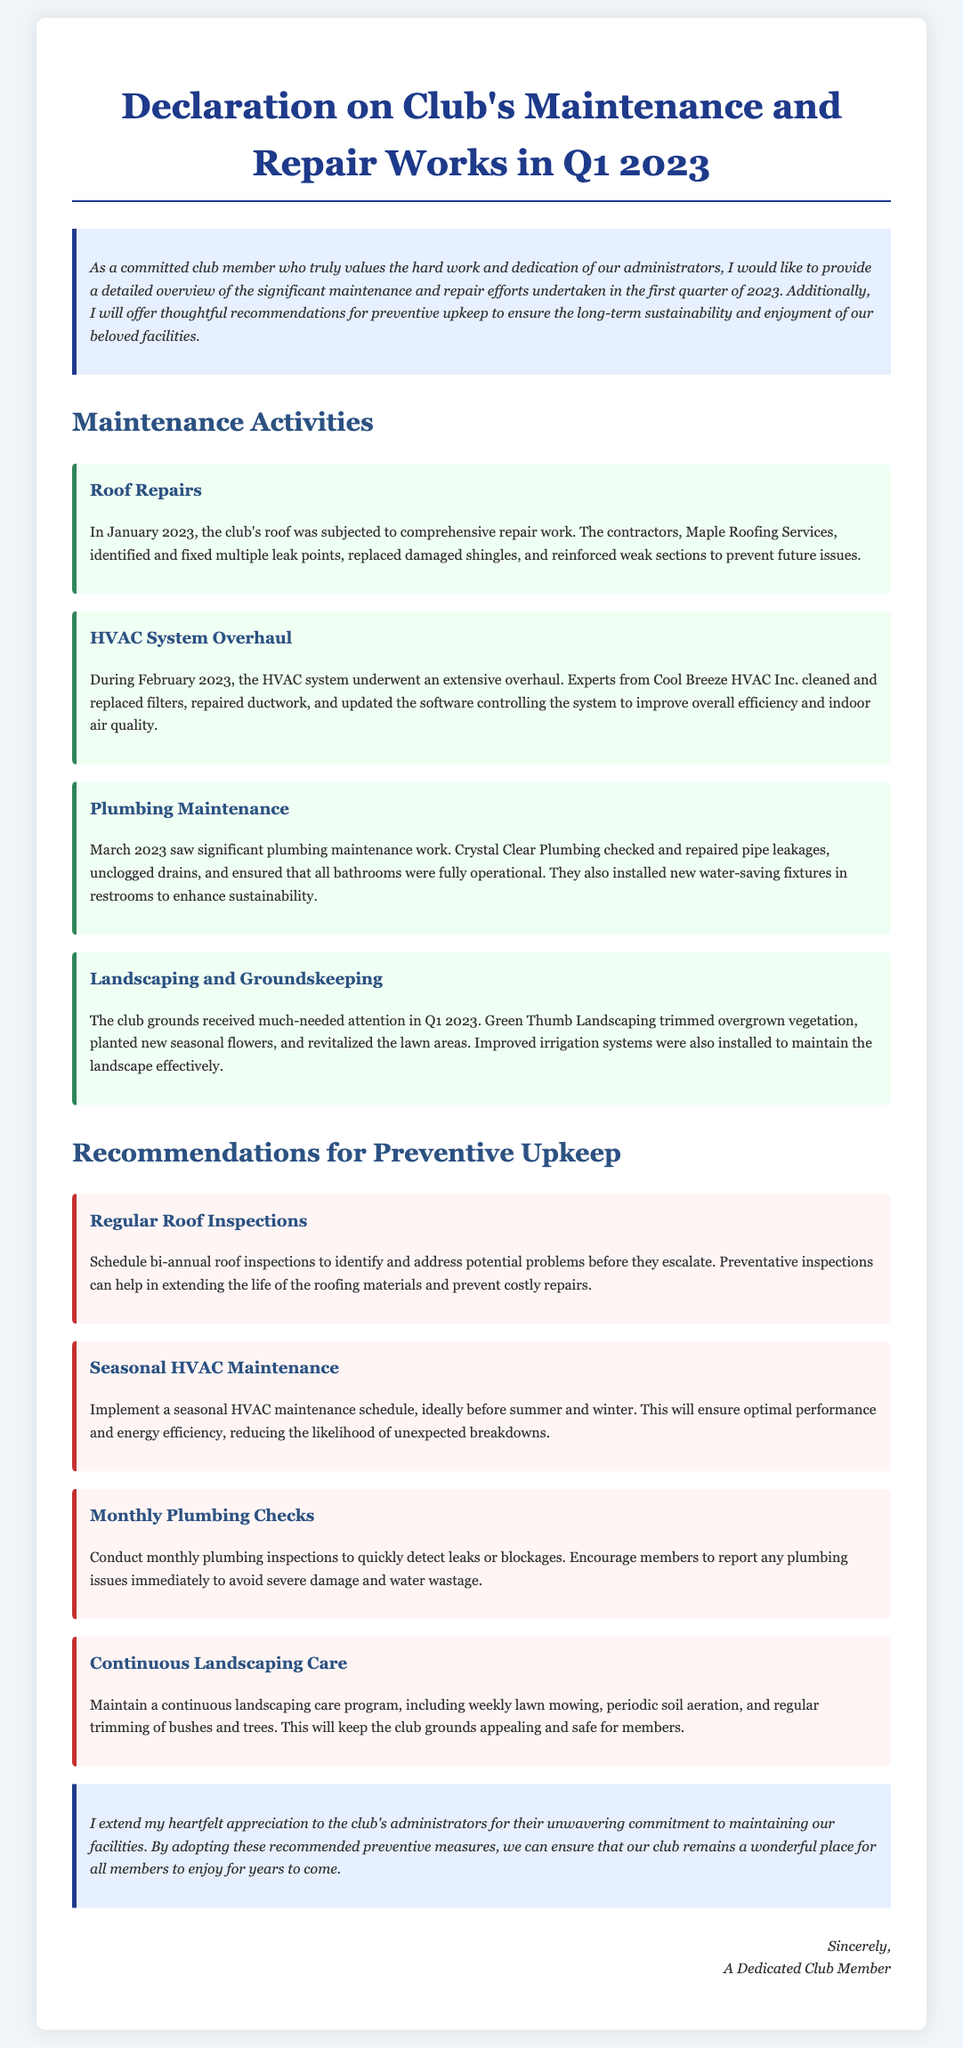What is the name of the roofing contractor? The document states that the contractors for the roof repairs were Maple Roofing Services.
Answer: Maple Roofing Services When was the plumbing maintenance conducted? According to the document, plumbing maintenance took place in March 2023.
Answer: March 2023 What is one recommendation for HVAC maintenance? The document suggests implementing a seasonal HVAC maintenance schedule before summer and winter.
Answer: Seasonal HVAC maintenance schedule How many landscaping activities are listed in the document? There are four distinct landscaping activities mentioned in the maintenance activities section.
Answer: Four What type of maintenance checks should be conducted monthly? The document indicates that monthly plumbing inspections should be conducted.
Answer: Plumbing inspections What is the primary goal of the preventive upkeep recommendations? The recommendations aim to ensure the long-term sustainability of the club facilities.
Answer: Long-term sustainability Who expressed appreciation for the administrators' efforts? The text mentions a "Dedicated Club Member" expressing appreciation.
Answer: A Dedicated Club Member What is the color theme used for the activity sections? The activity sections have a background color of light green.
Answer: Light green What maintenance activity took place in February 2023? The documentation states that the HVAC system underwent an extensive overhaul in February 2023.
Answer: HVAC system overhaul 